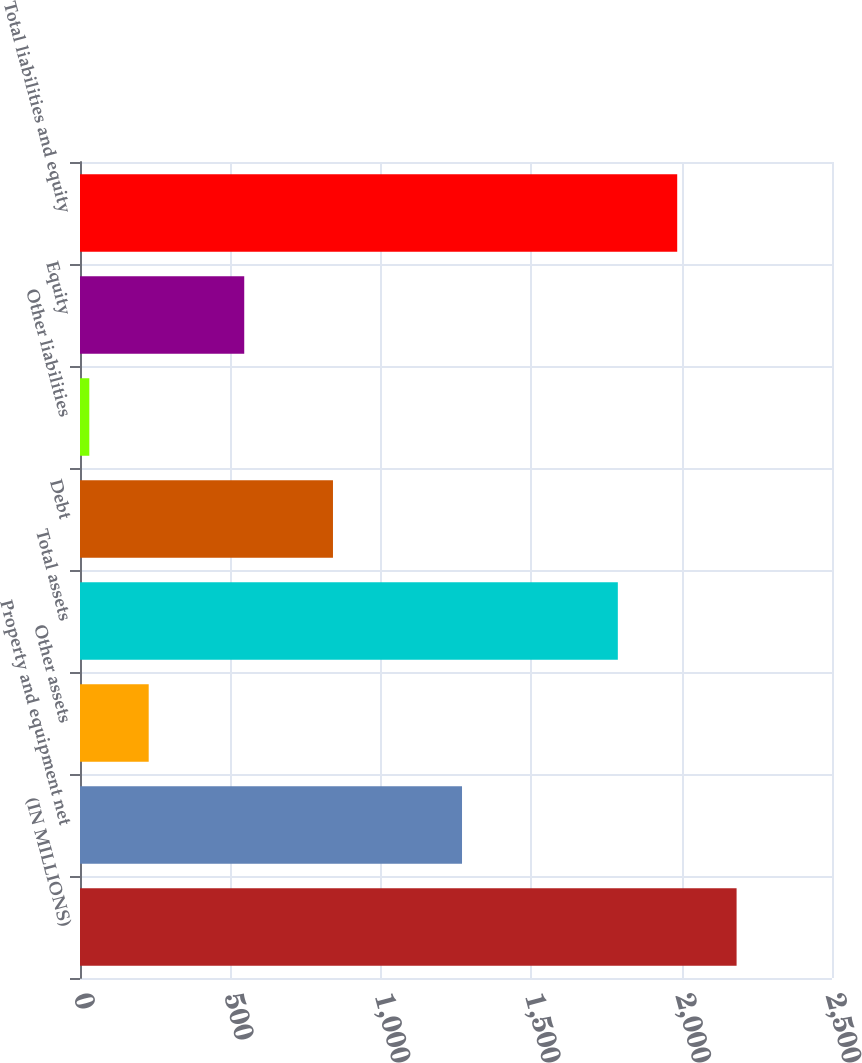Convert chart to OTSL. <chart><loc_0><loc_0><loc_500><loc_500><bar_chart><fcel>(IN MILLIONS)<fcel>Property and equipment net<fcel>Other assets<fcel>Total assets<fcel>Debt<fcel>Other liabilities<fcel>Equity<fcel>Total liabilities and equity<nl><fcel>2182.8<fcel>1270<fcel>228.4<fcel>1788<fcel>841<fcel>31<fcel>546<fcel>1985.4<nl></chart> 